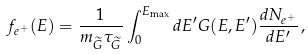<formula> <loc_0><loc_0><loc_500><loc_500>f _ { e ^ { + } } ( E ) = \frac { 1 } { m _ { \widetilde { G } } \tau _ { \widetilde { G } } } \int ^ { E _ { \max } } _ { 0 } d E ^ { \prime } G ( E , E ^ { \prime } ) \frac { d N _ { e ^ { + } } } { d E ^ { \prime } } \, ,</formula> 